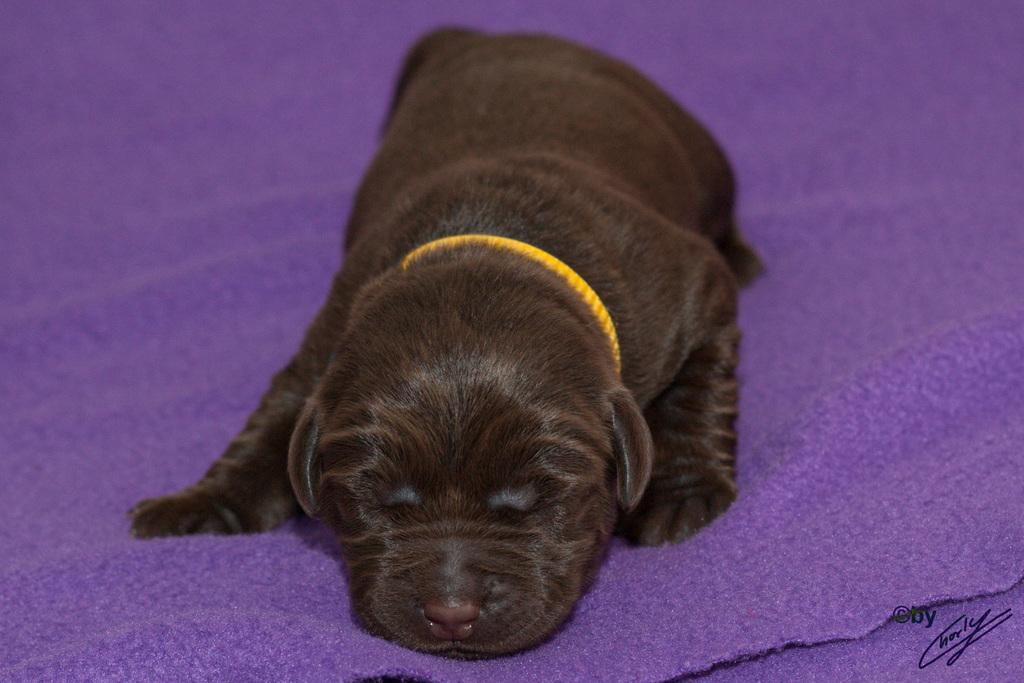What animal is present in the image? There is a dog in the image. What is the dog standing on? The dog is on a violet color carpet. Where can some text be found in the image? There is some text at the bottom right side of the image. What type of bone is the dog chewing on in the image? There is no bone present in the image; the dog is simply standing on the violet color carpet. 